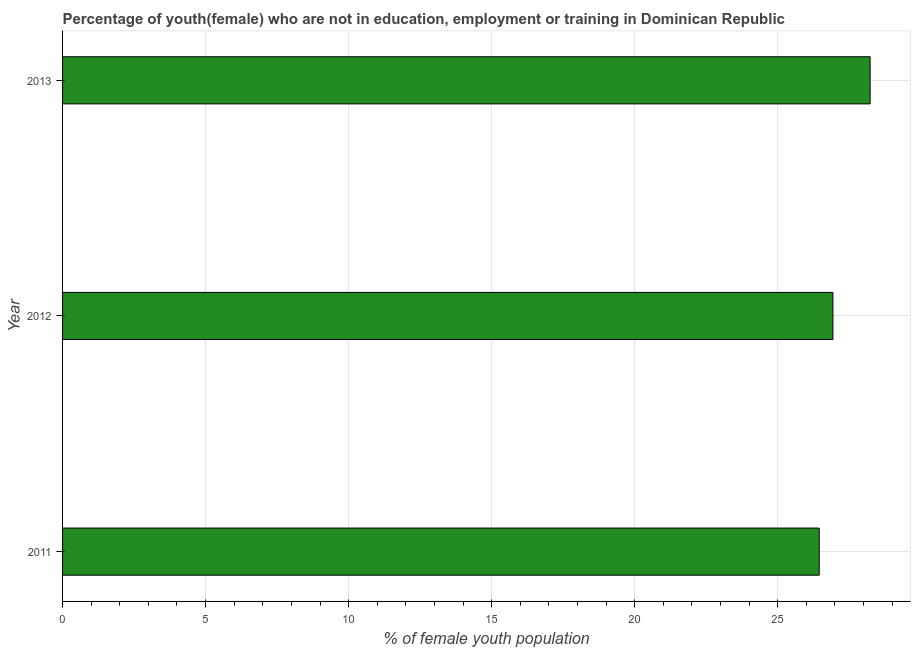Does the graph contain grids?
Offer a very short reply. Yes. What is the title of the graph?
Offer a terse response. Percentage of youth(female) who are not in education, employment or training in Dominican Republic. What is the label or title of the X-axis?
Give a very brief answer. % of female youth population. What is the label or title of the Y-axis?
Your answer should be compact. Year. What is the unemployed female youth population in 2013?
Keep it short and to the point. 28.23. Across all years, what is the maximum unemployed female youth population?
Provide a succinct answer. 28.23. Across all years, what is the minimum unemployed female youth population?
Make the answer very short. 26.45. What is the sum of the unemployed female youth population?
Your answer should be compact. 81.61. What is the difference between the unemployed female youth population in 2011 and 2012?
Keep it short and to the point. -0.48. What is the average unemployed female youth population per year?
Ensure brevity in your answer.  27.2. What is the median unemployed female youth population?
Provide a short and direct response. 26.93. In how many years, is the unemployed female youth population greater than 27 %?
Provide a succinct answer. 1. What is the ratio of the unemployed female youth population in 2012 to that in 2013?
Provide a short and direct response. 0.95. Is the difference between the unemployed female youth population in 2011 and 2012 greater than the difference between any two years?
Your response must be concise. No. What is the difference between the highest and the lowest unemployed female youth population?
Ensure brevity in your answer.  1.78. In how many years, is the unemployed female youth population greater than the average unemployed female youth population taken over all years?
Offer a terse response. 1. How many years are there in the graph?
Offer a terse response. 3. What is the difference between two consecutive major ticks on the X-axis?
Your answer should be very brief. 5. What is the % of female youth population in 2011?
Keep it short and to the point. 26.45. What is the % of female youth population in 2012?
Make the answer very short. 26.93. What is the % of female youth population of 2013?
Provide a succinct answer. 28.23. What is the difference between the % of female youth population in 2011 and 2012?
Provide a short and direct response. -0.48. What is the difference between the % of female youth population in 2011 and 2013?
Offer a very short reply. -1.78. What is the ratio of the % of female youth population in 2011 to that in 2013?
Ensure brevity in your answer.  0.94. What is the ratio of the % of female youth population in 2012 to that in 2013?
Your answer should be compact. 0.95. 